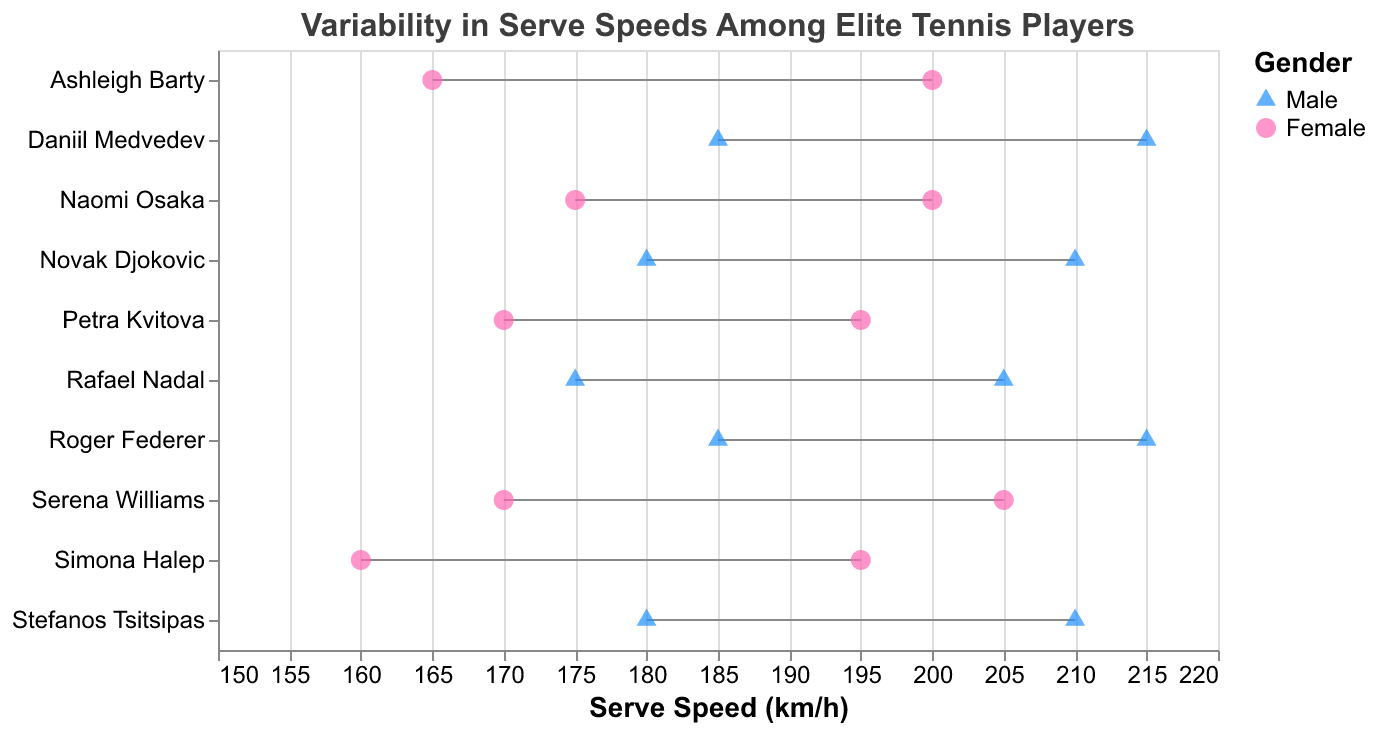How many players are shown in the chart? By counting the number of distinct dots or lines representing each player on the plot, we can identify the total number of players.
Answer: 10 Which player has the highest maximum serve speed? By inspecting the maximum serve speed values on the x-axis and finding the player corresponding to the highest value, we identify the player with the highest maximum serve speed.
Answer: Roger Federer and Daniil Medvedev What is the range of serve speeds for Serena Williams? By looking at Serena Williams’ serve speed line, we find the minimum and maximum values and calculate the difference (maximum - minimum).
Answer: 35 km/h Who has the lowest minimum serve speed? By examining the chart, the player with the lowest starting point on the x-axis for their range represents the lowest minimum serve speed.
Answer: Simona Halep What is the average maximum serve speed for female players? To find this, sum the maximum serve speeds for all female players and divide by the number of female players: (205 + 200 + 195 + 200 + 195) / 5 = 995 / 5
Answer: 199 km/h Compare the maximum serve speeds between Male and Female players, who reaches higher speeds on average? Calculate the average maximum serve speed for both genders and compare them. For males: (210 + 205 + 215 + 215 + 210) / 5 = 1055 / 5 = 211 km/h. For females: (205 + 200 + 195 + 200 + 195) / 5 = 995 / 5 = 199 km/h. Males have a higher average speed.
Answer: Male players Which gender shows greater variability in serve speeds? Variability can be visualized by the range of serve speeds for each gender. Measure the variability for each player and determine if one gender generally has wider ranges. Generally speaking, males tend to have slightly wider variability.
Answer: Male players What is the median maximum serve speed for all players combined? Arrange all maximum serve speeds in ascending order and find the middle value. If there is an even number of values, average the two middle numbers: (195, 195, 200, 200, 205, 205, 210, 210, 215, 215), the median is (205+205)/2 = 205 km/h.
Answer: 205 km/h Which player's serve speed range overlaps the most with the other players? Look for the player whose serve speed range intersects the ranges of the most other players. Naomi Osaka appears to have a range that overlaps with most other players.
Answer: Naomi Osaka 